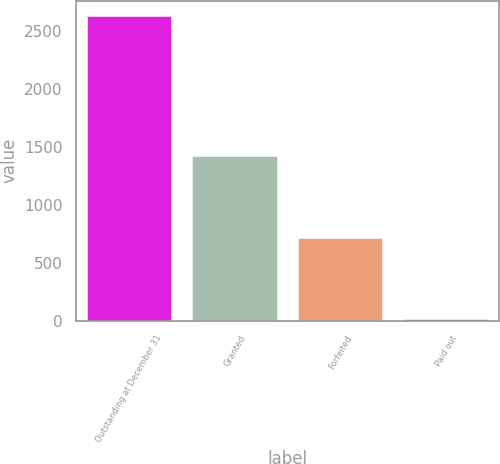Convert chart. <chart><loc_0><loc_0><loc_500><loc_500><bar_chart><fcel>Outstanding at December 31<fcel>Granted<fcel>Forfeited<fcel>Paid out<nl><fcel>2629<fcel>1421<fcel>716<fcel>15<nl></chart> 